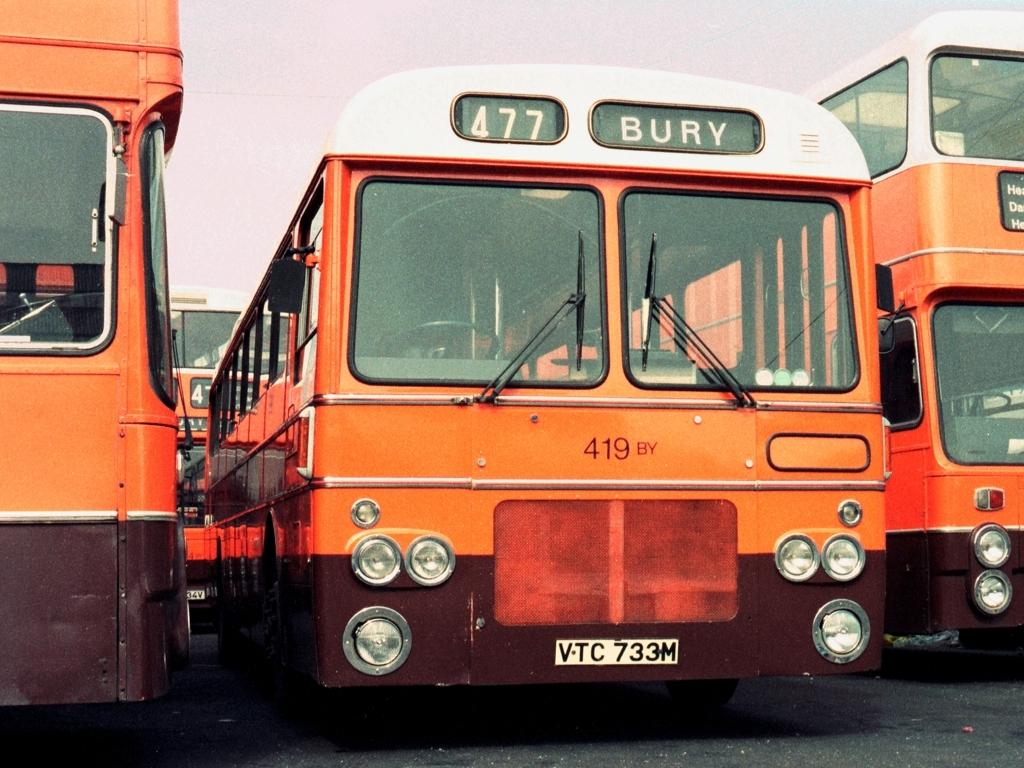Can you tell me about the era this bus comes from? Based on the design and registration plate, this bus appears to be from the 1970s, a time when this style of buses was common in the UK. 